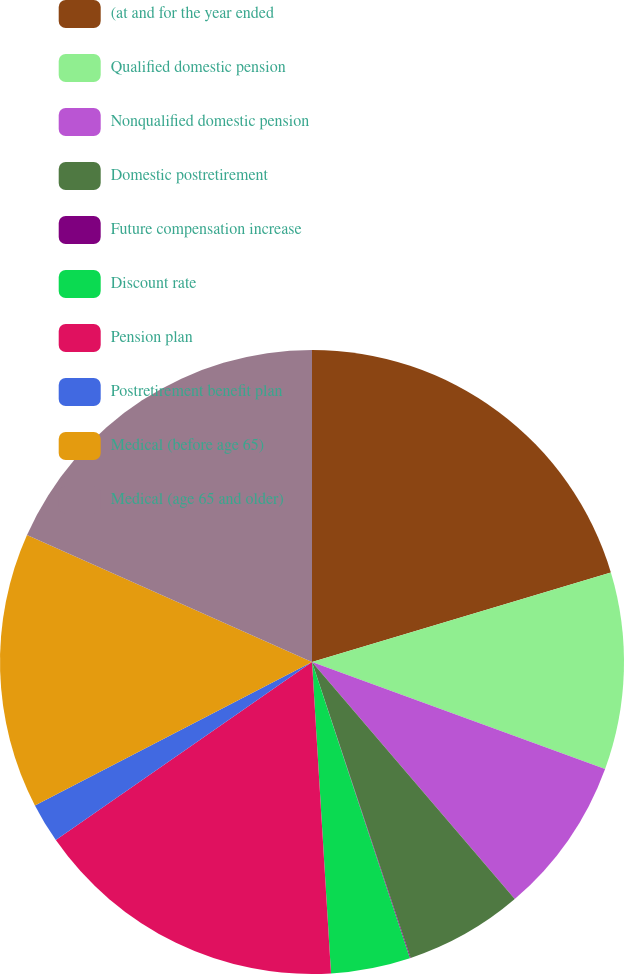<chart> <loc_0><loc_0><loc_500><loc_500><pie_chart><fcel>(at and for the year ended<fcel>Qualified domestic pension<fcel>Nonqualified domestic pension<fcel>Domestic postretirement<fcel>Future compensation increase<fcel>Discount rate<fcel>Pension plan<fcel>Postretirement benefit plan<fcel>Medical (before age 65)<fcel>Medical (age 65 and older)<nl><fcel>20.37%<fcel>10.2%<fcel>8.17%<fcel>6.14%<fcel>0.04%<fcel>4.11%<fcel>16.3%<fcel>2.07%<fcel>14.27%<fcel>18.33%<nl></chart> 